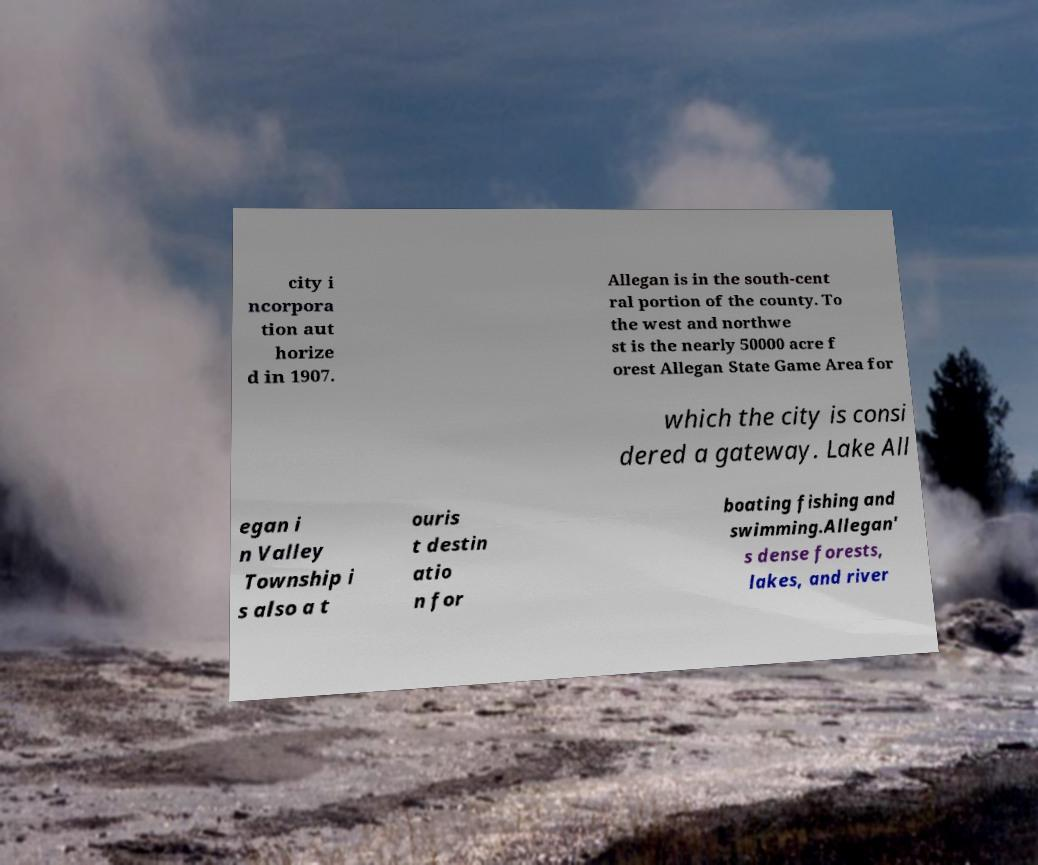Can you read and provide the text displayed in the image?This photo seems to have some interesting text. Can you extract and type it out for me? city i ncorpora tion aut horize d in 1907. Allegan is in the south-cent ral portion of the county. To the west and northwe st is the nearly 50000 acre f orest Allegan State Game Area for which the city is consi dered a gateway. Lake All egan i n Valley Township i s also a t ouris t destin atio n for boating fishing and swimming.Allegan' s dense forests, lakes, and river 